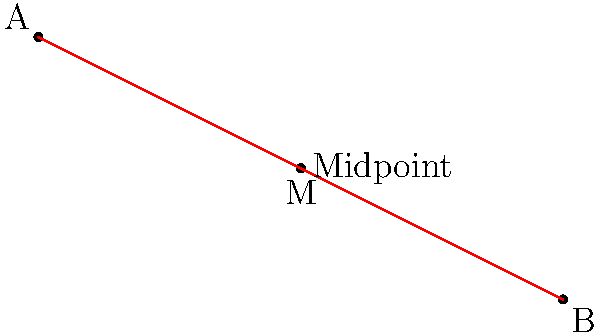In the Confucian concept of the "Doctrine of the Mean," balance and harmony are essential. This principle can be related to the midpoint formula in coordinate geometry. Given two points A(-3, 1) and B(5, -3), calculate the coordinates of the midpoint M. How does this midpoint reflect the Confucian idea of finding the middle way between extremes? To find the midpoint M between points A(-3, 1) and B(5, -3), we can apply the midpoint formula:

1. The midpoint formula is:
   $$ M = (\frac{x_1 + x_2}{2}, \frac{y_1 + y_2}{2}) $$

2. Substituting the x-coordinates:
   $$ x_M = \frac{-3 + 5}{2} = \frac{2}{2} = 1 $$

3. Substituting the y-coordinates:
   $$ y_M = \frac{1 + (-3)}{2} = \frac{-2}{2} = -1 $$

4. Therefore, the midpoint M has coordinates (1, -1).

This midpoint reflects the Confucian idea of the "Doctrine of the Mean" by representing a balance between two extremes. Just as the midpoint is equidistant from both endpoints, the Confucian philosophy emphasizes finding a middle path between opposing viewpoints or actions. This balance is seen as a way to achieve harmony and avoid excess in either direction, much like how the midpoint formula finds the exact center between two points on a coordinate plane.
Answer: M(1, -1); represents balance between extremes 